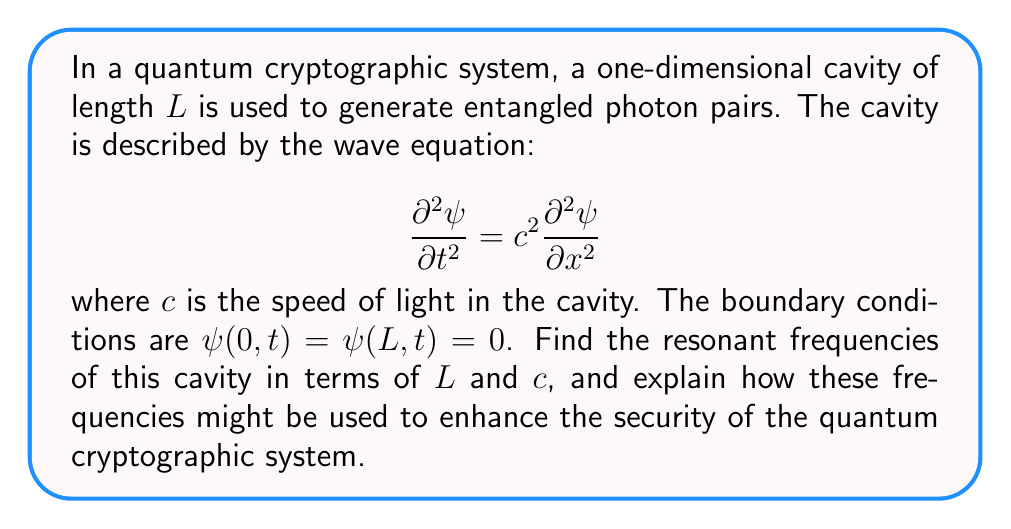Can you answer this question? To solve this problem, we'll follow these steps:

1) First, we assume a separable solution of the form:
   $$\psi(x,t) = X(x)T(t)$$

2) Substituting this into the wave equation:
   $$X(x)T''(t) = c^2X''(x)T(t)$$

3) Dividing both sides by $X(x)T(t)$:
   $$\frac{T''(t)}{T(t)} = c^2\frac{X''(x)}{X(x)} = -\omega^2$$
   where $\omega^2$ is a constant.

4) This gives us two equations:
   $$T''(t) + \omega^2T(t) = 0$$
   $$X''(x) + \frac{\omega^2}{c^2}X(x) = 0$$

5) The general solution for $X(x)$ is:
   $$X(x) = A\sin(\frac{\omega x}{c}) + B\cos(\frac{\omega x}{c})$$

6) Applying the boundary conditions:
   $X(0) = 0$ implies $B = 0$
   $X(L) = 0$ implies $A\sin(\frac{\omega L}{c}) = 0$

7) For non-trivial solutions, we must have:
   $$\frac{\omega L}{c} = n\pi, \quad n = 1,2,3,...$$

8) Solving for $\omega$:
   $$\omega_n = \frac{n\pi c}{L}, \quad n = 1,2,3,...$$

9) The resonant frequencies are given by:
   $$f_n = \frac{\omega_n}{2\pi} = \frac{nc}{2L}, \quad n = 1,2,3,...$$

These resonant frequencies can enhance the security of the quantum cryptographic system by:
a) Providing a unique "fingerprint" for the system, making it harder for an attacker to mimic.
b) Allowing for precise control of photon generation, which is crucial for quantum key distribution.
c) Enabling the creation of frequency-entangled photon pairs, which can be used for secure communication protocols.
Answer: $f_n = \frac{nc}{2L}, \quad n = 1,2,3,...$ 